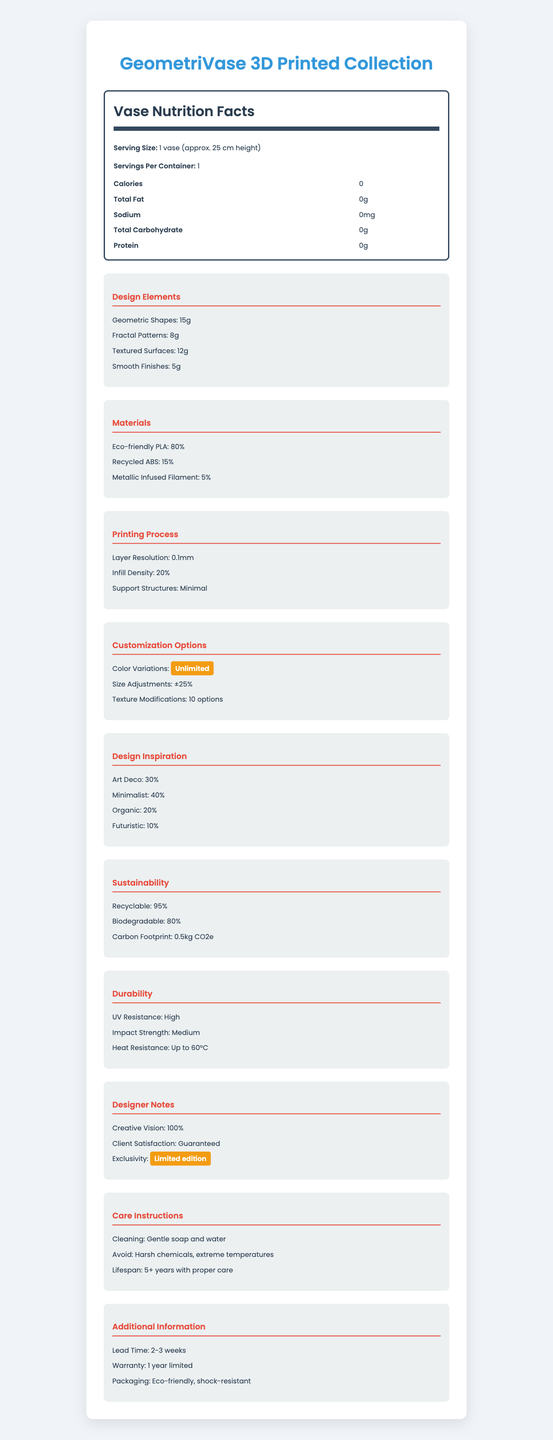what is the serving size for the vases? The serving size is listed as "1 vase (approx. 25 cm height)" in the document.
Answer: 1 vase (approx. 25 cm height) how many design elements are listed? The document lists four design elements: geometric shapes, fractal patterns, textured surfaces, and smooth finishes.
Answer: 4 what is the percentage of eco-friendly PLA in the materials? The percentage of eco-friendly PLA is specified to be 80%.
Answer: 80% what is the lead time for the vases? The lead time for the vases is stated as "2-3 weeks."
Answer: 2-3 weeks what care instructions are provided for cleaning the vases? The care instructions for cleaning the vases are "Gentle soap and water."
Answer: Gentle soap and water Which of the following is a material used in the vases? A. Polystyrene B. Recycled ABS C. Glass The materials listed include eco-friendly PLA, recycled ABS, and metallic infused filament. Therefore, B. Recycled ABS is correct.
Answer: B What is the infill density mentioned for the printing process? A. 10% B. 30% C. 20% D. 40% The document specifies the infill density as "20%."
Answer: C Are the vases recyclable? The document mentions that the vases are "95% recyclable."
Answer: Yes Summarize the main idea of the document. The document describes various aspects of the GeometriVase 3D Printed Collection, such as its components, creative and technical details, and maintenance guidelines, aiming to inform potential buyers or users about the product.
Answer: The document provides detailed information about the GeometriVase 3D Printed Collection, including its design elements, materials, printing process, customization options, design inspiration, sustainability, durability, care instructions, additional information, and designer notes. What is the color of the packaging used for the vases? The document mentions that the packaging is eco-friendly and shock-resistant but does not specify its color.
Answer: Cannot be determined 